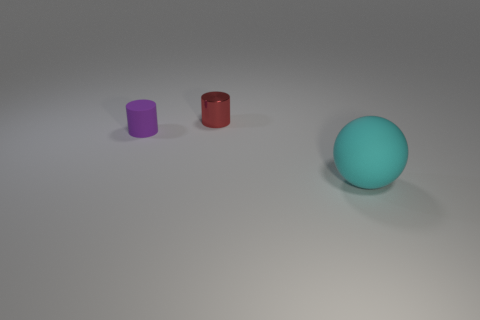Subtract all purple cylinders. How many cylinders are left? 1 Subtract all red cylinders. Subtract all blue blocks. How many cylinders are left? 1 Subtract all yellow balls. How many purple cylinders are left? 1 Subtract all gray cylinders. Subtract all small purple cylinders. How many objects are left? 2 Add 3 red cylinders. How many red cylinders are left? 4 Add 2 small yellow metal cubes. How many small yellow metal cubes exist? 2 Add 1 rubber cylinders. How many objects exist? 4 Subtract 0 green blocks. How many objects are left? 3 Subtract all spheres. How many objects are left? 2 Subtract 1 balls. How many balls are left? 0 